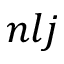<formula> <loc_0><loc_0><loc_500><loc_500>n l j</formula> 